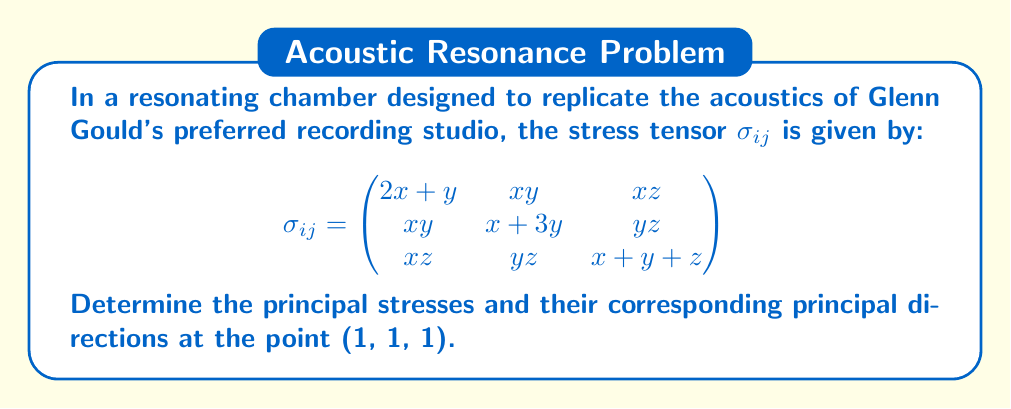Teach me how to tackle this problem. To find the principal stresses and their directions, we need to solve the eigenvalue problem for the stress tensor at the given point.

Step 1: Evaluate the stress tensor at (1, 1, 1):
$$\sigma_{ij} = \begin{pmatrix}
3 & 1 & 1 \\
1 & 4 & 1 \\
1 & 1 & 3
\end{pmatrix}$$

Step 2: Set up the characteristic equation:
$$\det(\sigma_{ij} - \lambda I) = 0$$

$$\begin{vmatrix}
3-\lambda & 1 & 1 \\
1 & 4-\lambda & 1 \\
1 & 1 & 3-\lambda
\end{vmatrix} = 0$$

Step 3: Expand the determinant:
$$(3-\lambda)(4-\lambda)(3-\lambda) - (3-\lambda) - (4-\lambda) - (3-\lambda) = 0$$
$$-\lambda^3 + 10\lambda^2 - 31\lambda + 30 = 0$$

Step 4: Solve the cubic equation. The roots are the principal stresses:
$$\lambda_1 = 5, \lambda_2 = 3, \lambda_3 = 2$$

Step 5: For each eigenvalue, solve $(\sigma_{ij} - \lambda I)\vec{v} = 0$ to find the eigenvectors:

For $\lambda_1 = 5$:
$$\begin{pmatrix}
-2 & 1 & 1 \\
1 & -1 & 1 \\
1 & 1 & -2
\end{pmatrix}\vec{v_1} = 0$$
$\vec{v_1} = (1, 1, 1)$

For $\lambda_2 = 3$:
$$\begin{pmatrix}
0 & 1 & 1 \\
1 & 1 & 1 \\
1 & 1 & 0
\end{pmatrix}\vec{v_2} = 0$$
$\vec{v_2} = (1, -1, 0)$

For $\lambda_3 = 2$:
$$\begin{pmatrix}
1 & 1 & 1 \\
1 & 2 & 1 \\
1 & 1 & 1
\end{pmatrix}\vec{v_3} = 0$$
$\vec{v_3} = (1, -2, 1)$

Step 6: Normalize the eigenvectors to get the principal directions:
$\hat{v_1} = \frac{1}{\sqrt{3}}(1, 1, 1)$
$\hat{v_2} = \frac{1}{\sqrt{2}}(1, -1, 0)$
$\hat{v_3} = \frac{1}{\sqrt{6}}(1, -2, 1)$
Answer: Principal stresses: 5, 3, 2
Principal directions: $\frac{1}{\sqrt{3}}(1, 1, 1)$, $\frac{1}{\sqrt{2}}(1, -1, 0)$, $\frac{1}{\sqrt{6}}(1, -2, 1)$ 